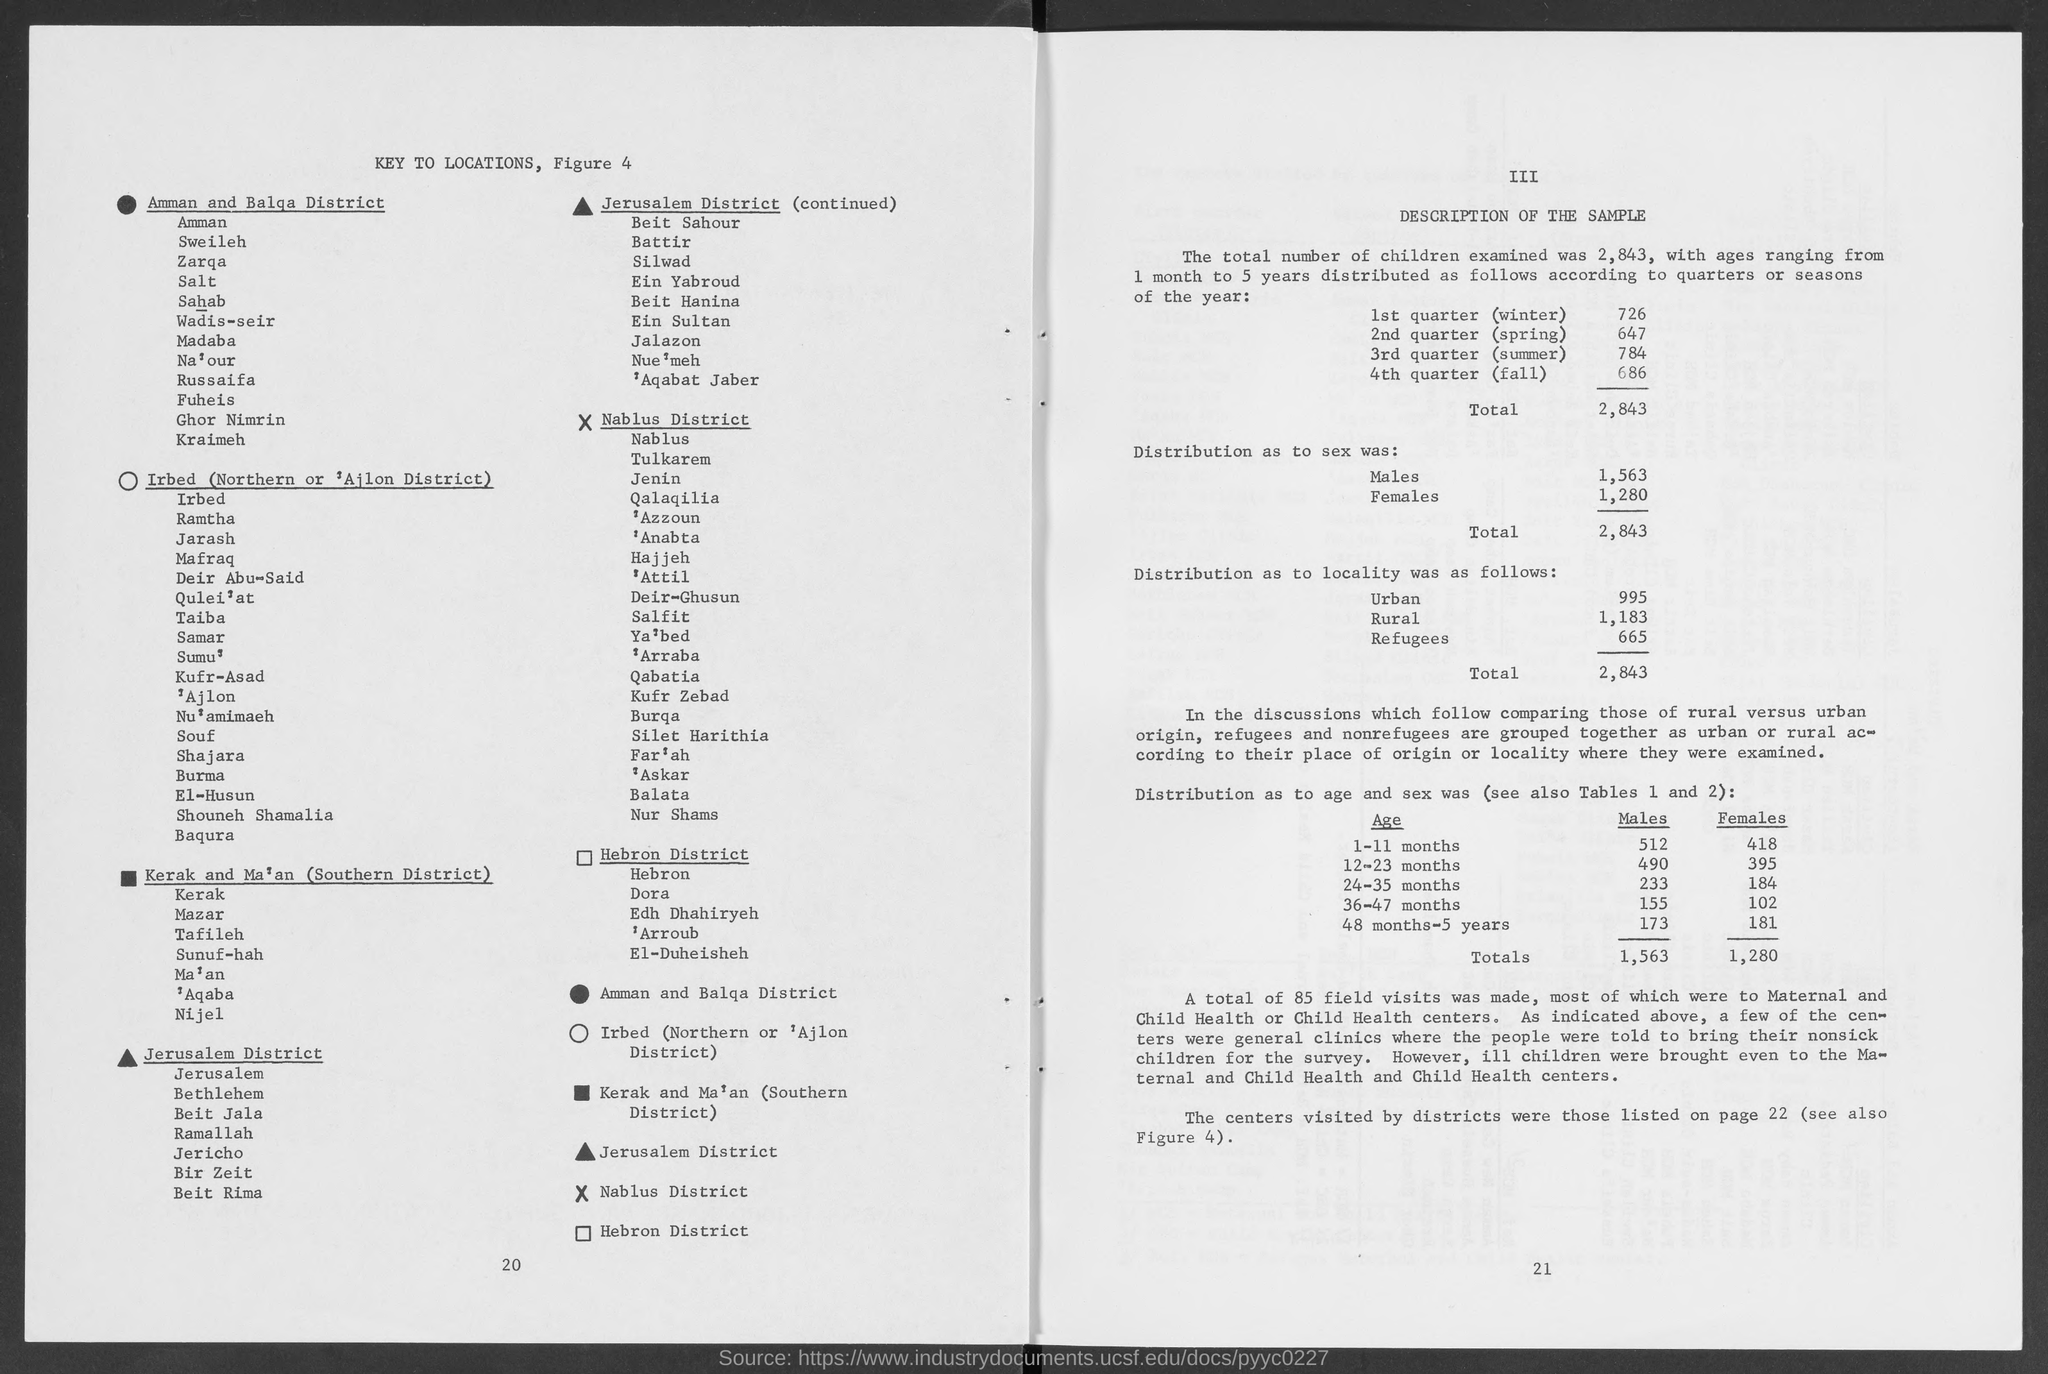What is the number at bottom right page?
Provide a short and direct response. 21. What is the number at bottom of left page?
Your answer should be very brief. 20. 